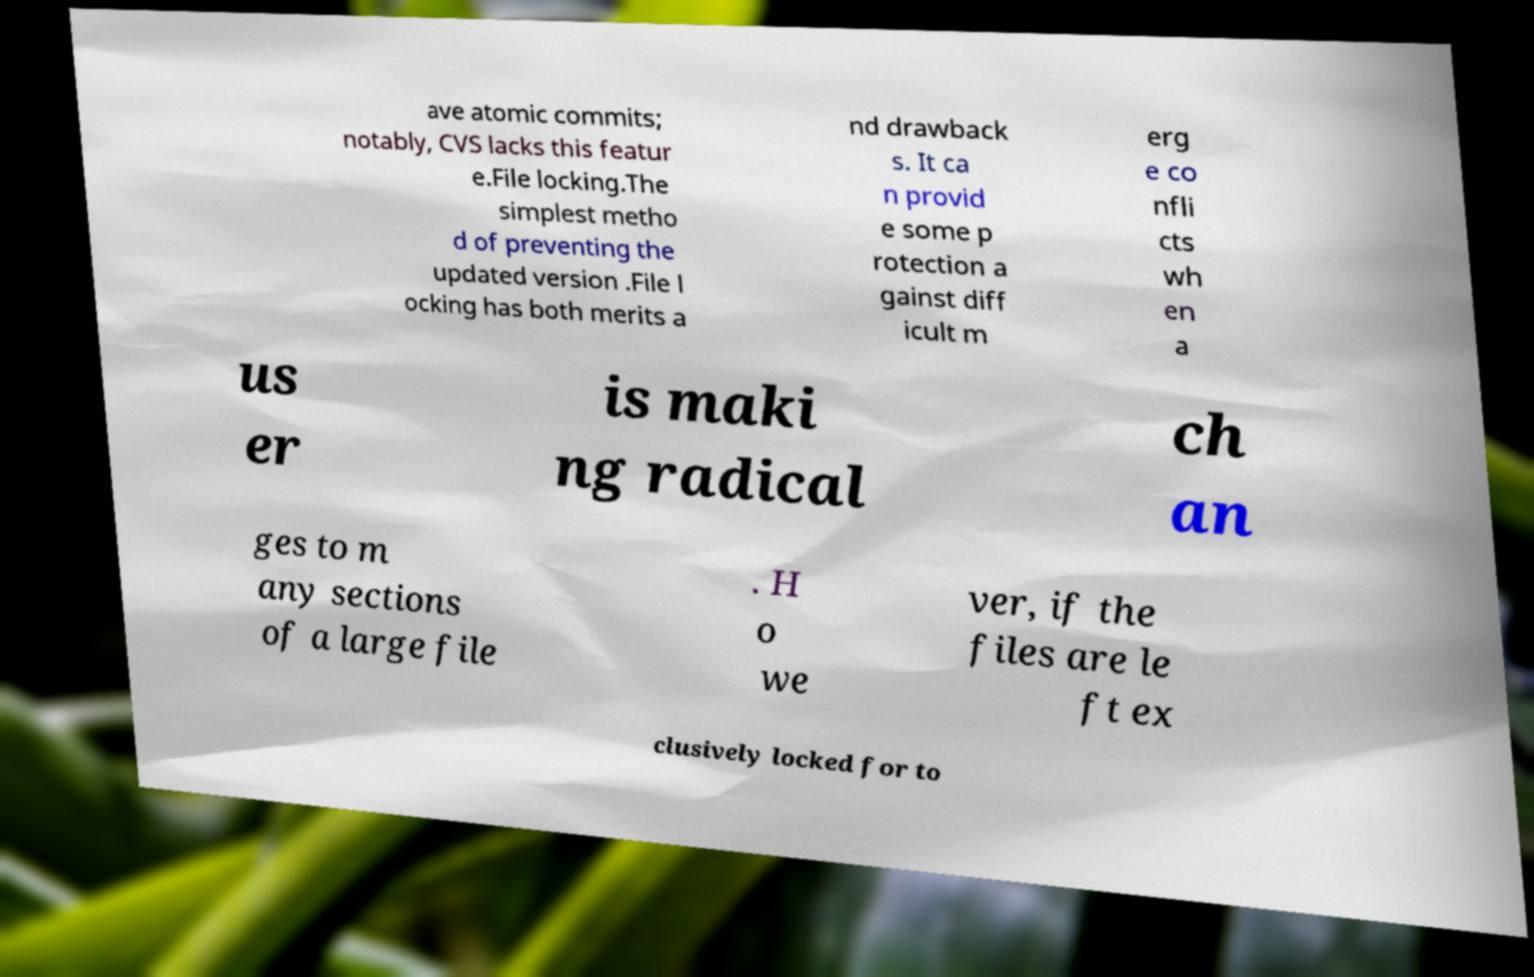Could you extract and type out the text from this image? ave atomic commits; notably, CVS lacks this featur e.File locking.The simplest metho d of preventing the updated version .File l ocking has both merits a nd drawback s. It ca n provid e some p rotection a gainst diff icult m erg e co nfli cts wh en a us er is maki ng radical ch an ges to m any sections of a large file . H o we ver, if the files are le ft ex clusively locked for to 